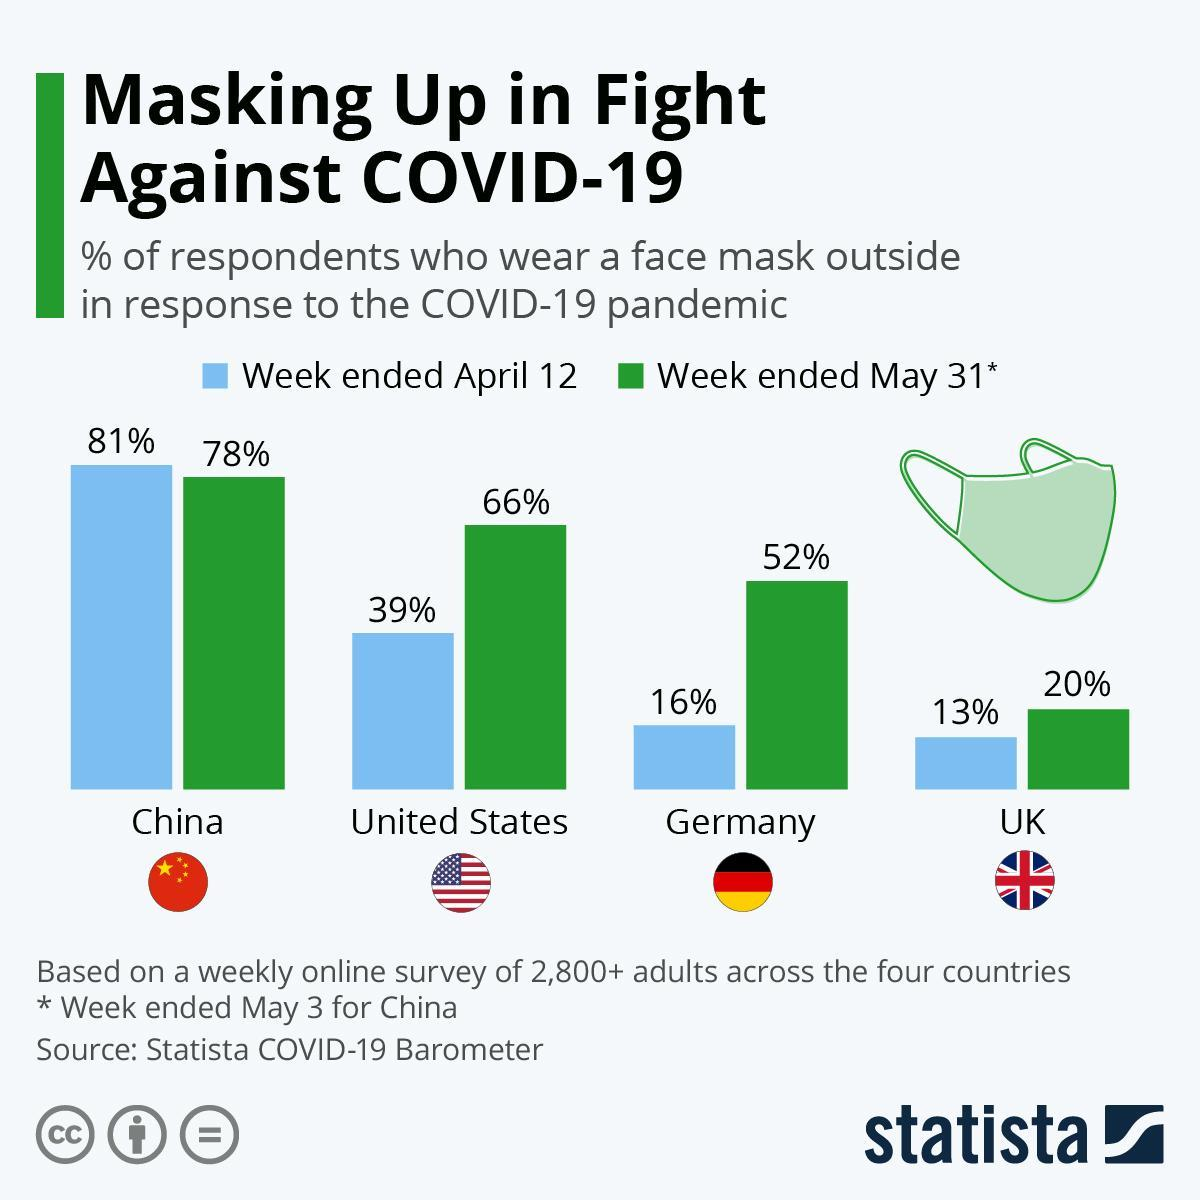What are the three colours on German flag- black,red,yellow or green,blue,white?
Answer the question with a short phrase. black, red, yellow How many masks are shown in the infographic? 1 By what percent did people wearing masks increase in Germany from April to May? 36% Which country had respondents wearing masks drop by the week ended May 31st? China In which country did the percentage of respondents wearing face mask increase by 27% from April to May? United States How many flags are shown? 4 